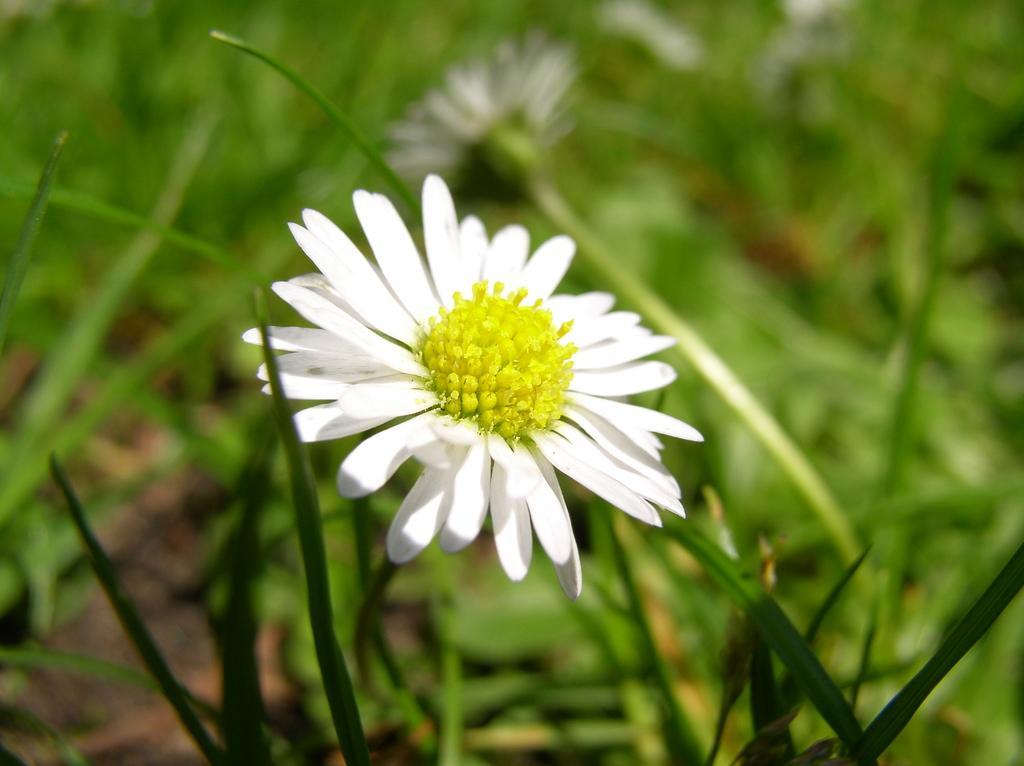How would you summarize this image in a sentence or two? In this image I can see the flowers to the plant. These flowers are in white and green color. And the plants are also in green color. 